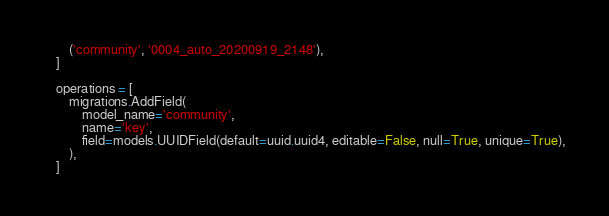Convert code to text. <code><loc_0><loc_0><loc_500><loc_500><_Python_>        ('community', '0004_auto_20200919_2148'),
    ]

    operations = [
        migrations.AddField(
            model_name='community',
            name='key',
            field=models.UUIDField(default=uuid.uuid4, editable=False, null=True, unique=True),
        ),
    ]
</code> 